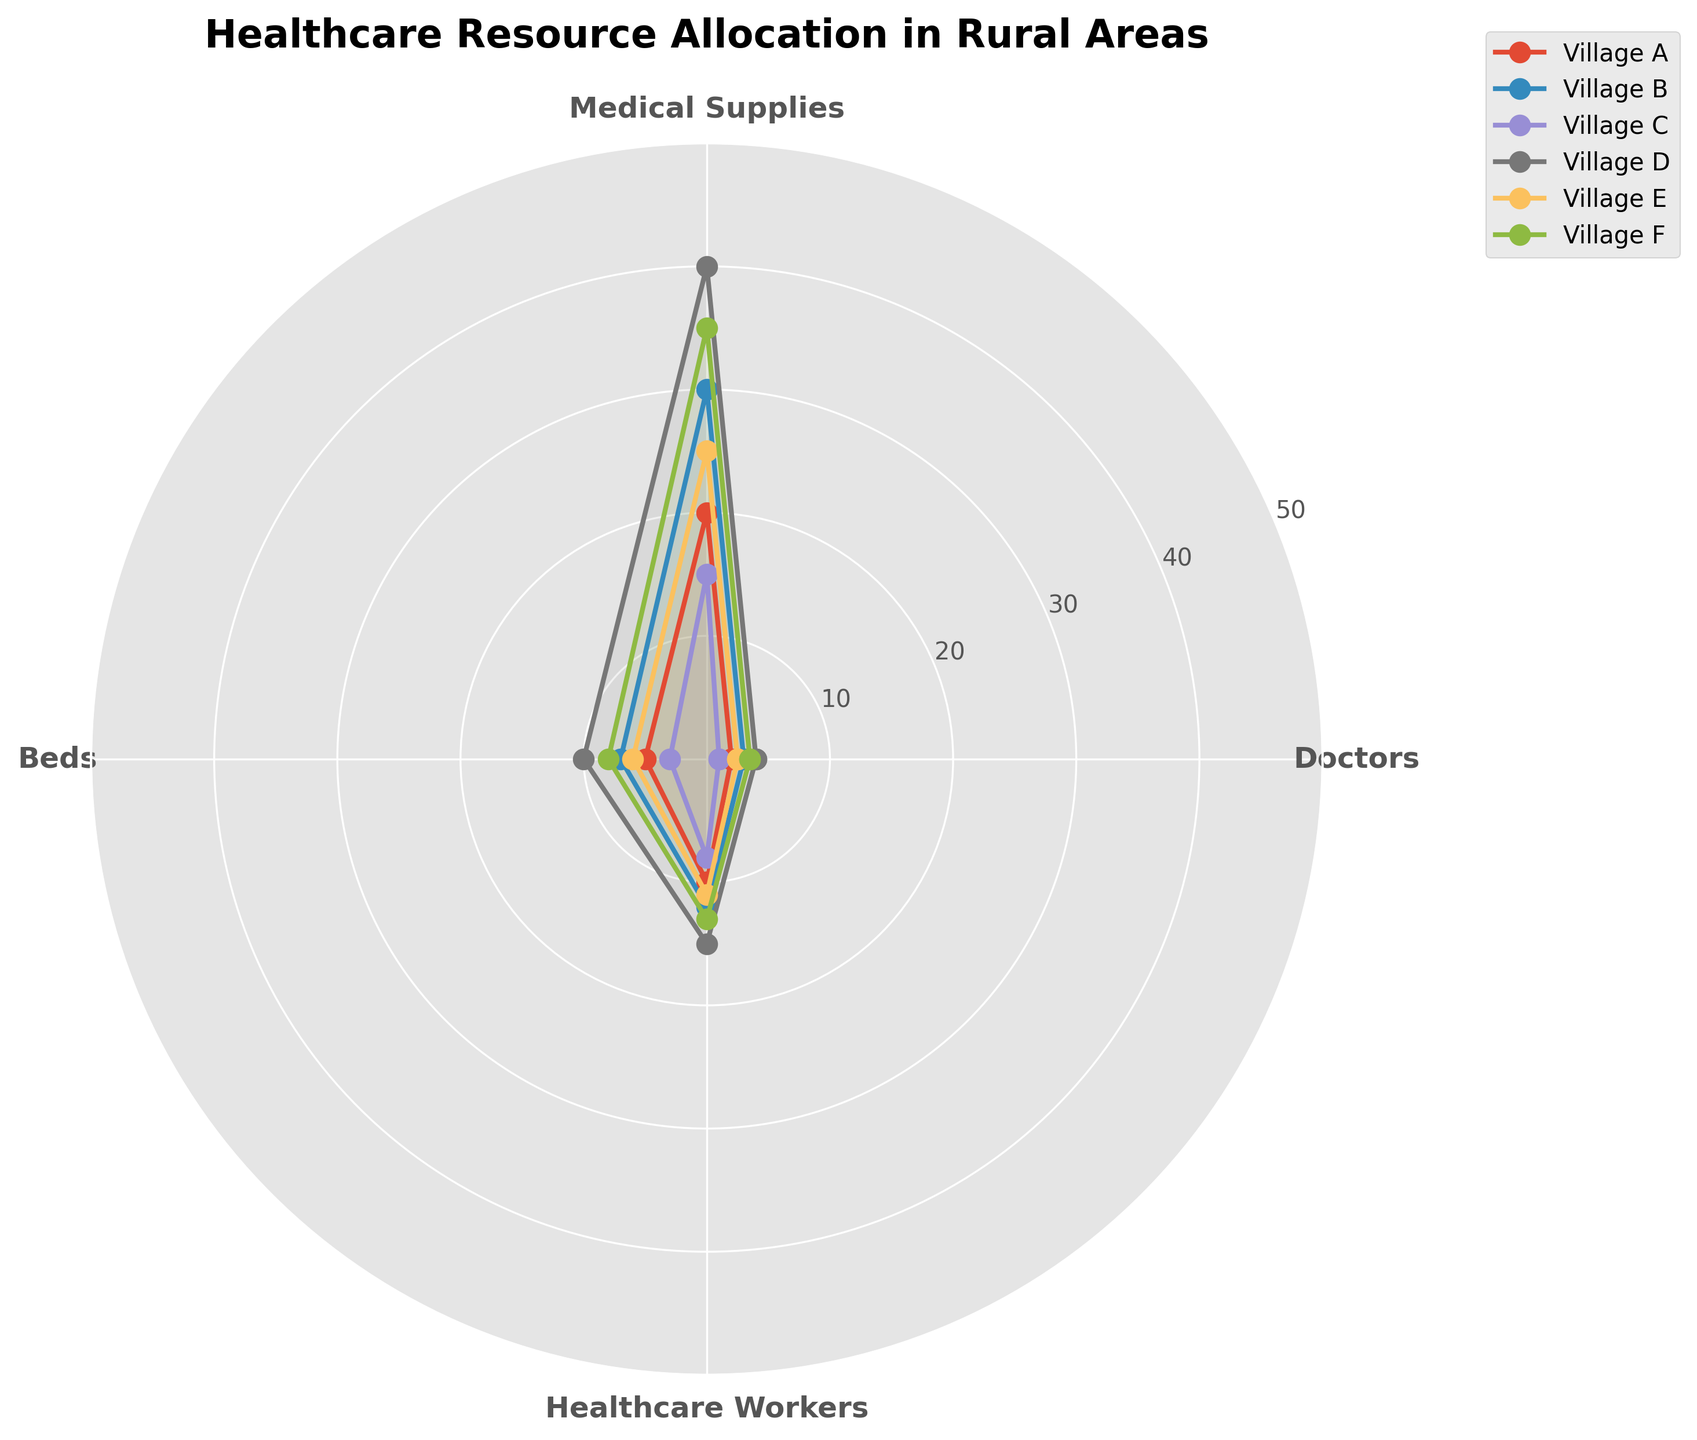What's the title of the figure? The title is typically placed at the top of the chart. In this case, it is mentioned in the data that the title of the plot is “Healthcare Resource Allocation in Rural Areas”.
Answer: Healthcare Resource Allocation in Rural Areas How many healthcare workers are there in Village D? Find the angle that corresponds to "Healthcare Workers" and then trace the value for Village D along that angle. From the provided data, the value for healthcare workers in Village D is 15.
Answer: 15 Which village has the highest number of doctors? Locate the angle that represents "Doctors". Compare the values for each village along this angle. Village D, with a value of 4, has the highest number of doctors.
Answer: Village D What's the average number of medical supplies across all villages? Sum up the values of medical supplies for each village (20 + 30 + 15 + 40 + 25 + 35 = 165). There are 6 villages, so divide the sum by 6. The average is 165 / 6 ≈ 27.5.
Answer: 27.5 Which village has fewer beds than the average number of beds across all villages? Sum the bed values (5 + 7 + 3 + 10 + 6 + 8 = 39). The average is 39 / 6 = 6.5. Compare each village's bed value to see which are below 6.5. Village A (5), Village C (3), and Village E (6) have fewer beds than the average.
Answer: Village A, Village C, Village E What's the difference between the number of doctors in Village B and Village F? From the chart, Village B has 3 doctors and Village F has 3.5 doctors. The difference is 3.5 - 3 = 0.5.
Answer: 0.5 Which category shows the most noticeable disparity among villages? Look around the radar chart visually to determine which category (Doctors, Medical Supplies, Beds, Healthcare Workers) has the widest range of values. "Medical Supplies" shows significant disparity, ranging from 15 to 40.
Answer: Medical Supplies What is the total number of healthcare workers in villages with a population density greater than 60 per sq km? Check the population density for Village B (12), Village D (15), and Village F (13), as they meet the criterion (> 60 per sq km). Sum healthcare workers (12 + 15 + 13 = 40).
Answer: 40 Which village has an equal amount of doctors and beds? Compare the values for doctors and beds in each village to find any matches. Village D has 4 doctors and 10 beds, no matches. Village A has 2 doctors and 5 beds, no match. Only Village B has a hypothetical scenario of 3 doctors and 7 beds. No village matches exactly based on the data.
Answer: None 